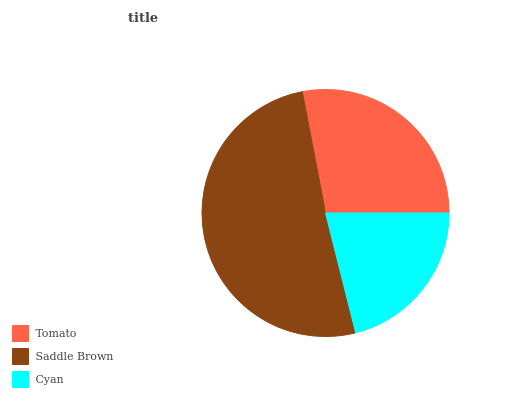Is Cyan the minimum?
Answer yes or no. Yes. Is Saddle Brown the maximum?
Answer yes or no. Yes. Is Saddle Brown the minimum?
Answer yes or no. No. Is Cyan the maximum?
Answer yes or no. No. Is Saddle Brown greater than Cyan?
Answer yes or no. Yes. Is Cyan less than Saddle Brown?
Answer yes or no. Yes. Is Cyan greater than Saddle Brown?
Answer yes or no. No. Is Saddle Brown less than Cyan?
Answer yes or no. No. Is Tomato the high median?
Answer yes or no. Yes. Is Tomato the low median?
Answer yes or no. Yes. Is Saddle Brown the high median?
Answer yes or no. No. Is Saddle Brown the low median?
Answer yes or no. No. 